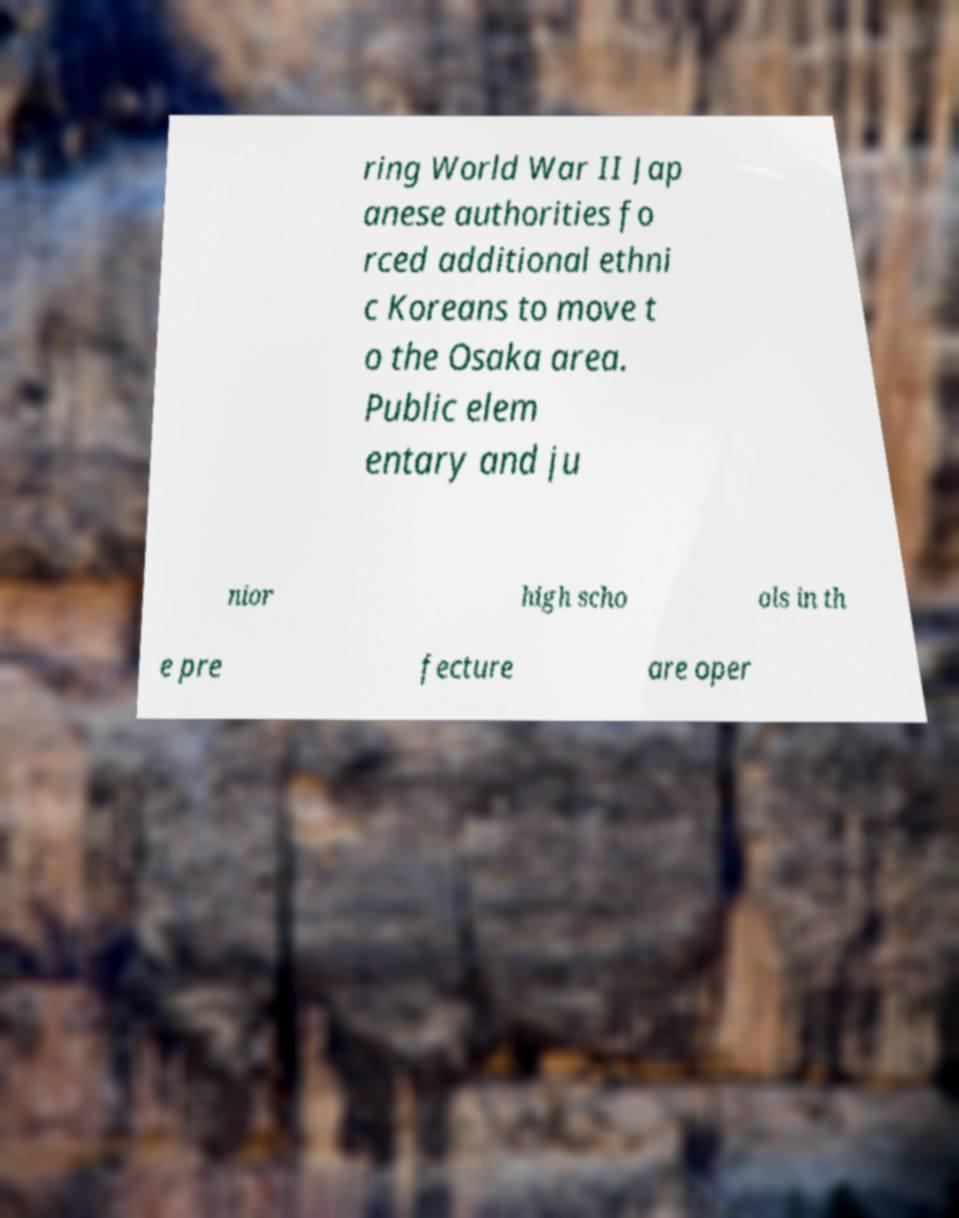For documentation purposes, I need the text within this image transcribed. Could you provide that? ring World War II Jap anese authorities fo rced additional ethni c Koreans to move t o the Osaka area. Public elem entary and ju nior high scho ols in th e pre fecture are oper 